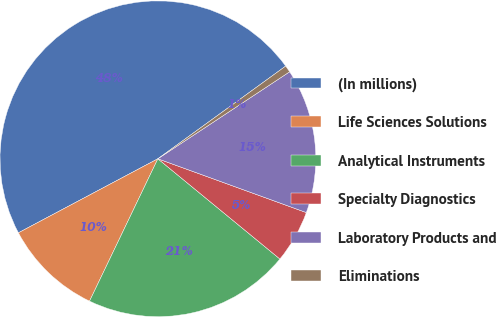Convert chart to OTSL. <chart><loc_0><loc_0><loc_500><loc_500><pie_chart><fcel>(In millions)<fcel>Life Sciences Solutions<fcel>Analytical Instruments<fcel>Specialty Diagnostics<fcel>Laboratory Products and<fcel>Eliminations<nl><fcel>47.78%<fcel>10.11%<fcel>21.18%<fcel>5.41%<fcel>14.82%<fcel>0.7%<nl></chart> 